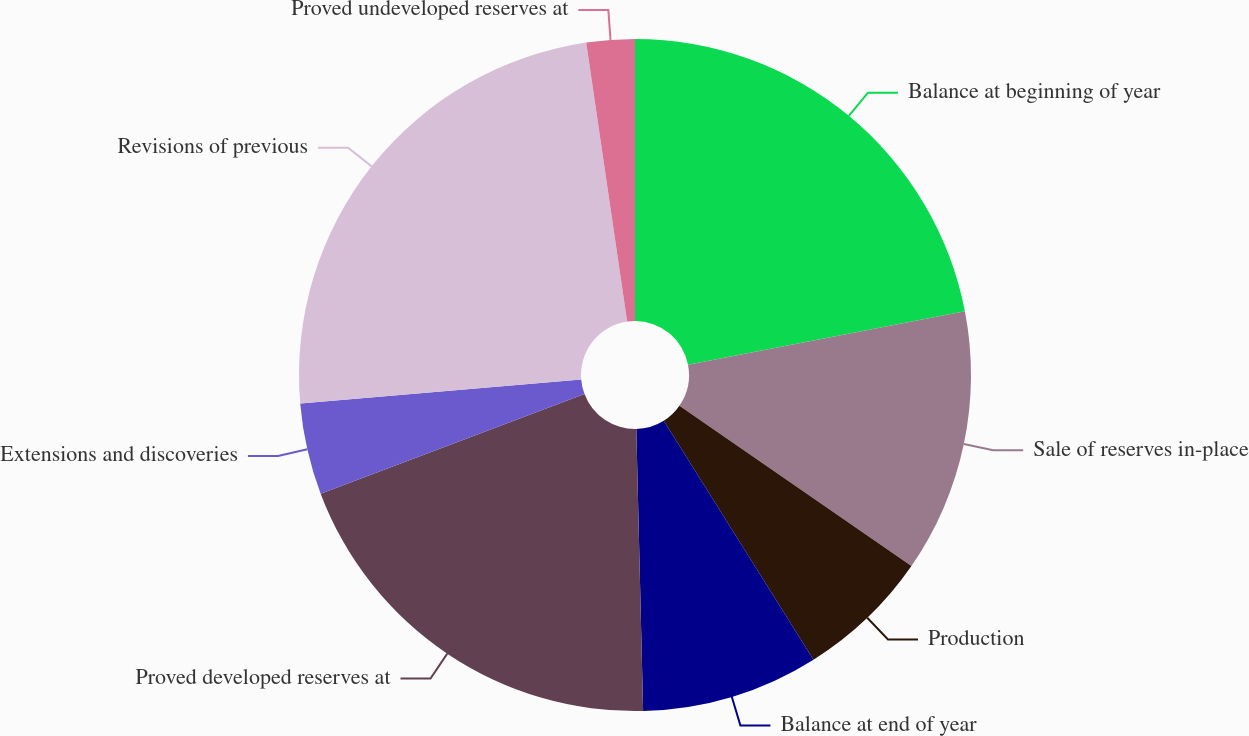Convert chart. <chart><loc_0><loc_0><loc_500><loc_500><pie_chart><fcel>Balance at beginning of year<fcel>Sale of reserves in-place<fcel>Production<fcel>Balance at end of year<fcel>Proved developed reserves at<fcel>Extensions and discoveries<fcel>Revisions of previous<fcel>Proved undeveloped reserves at<nl><fcel>21.96%<fcel>12.66%<fcel>6.46%<fcel>8.53%<fcel>19.64%<fcel>4.39%<fcel>24.03%<fcel>2.32%<nl></chart> 